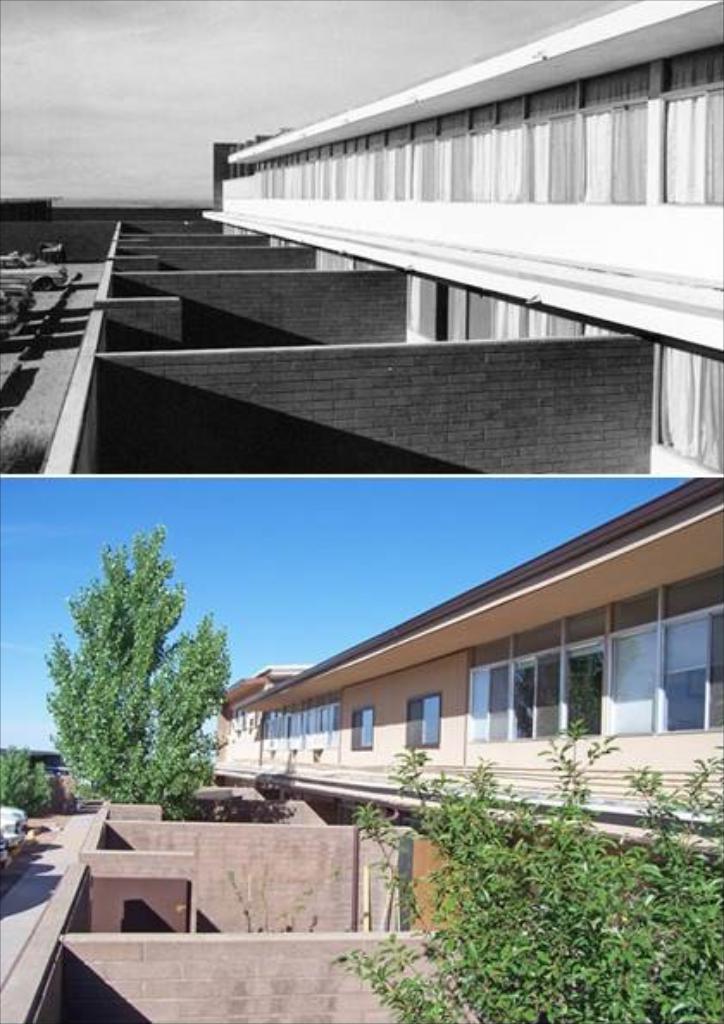How would you summarize this image in a sentence or two? In the foreground of the image we can see the building, walls, trees and cars. On the top of the image we can see a building, walls and cars. 